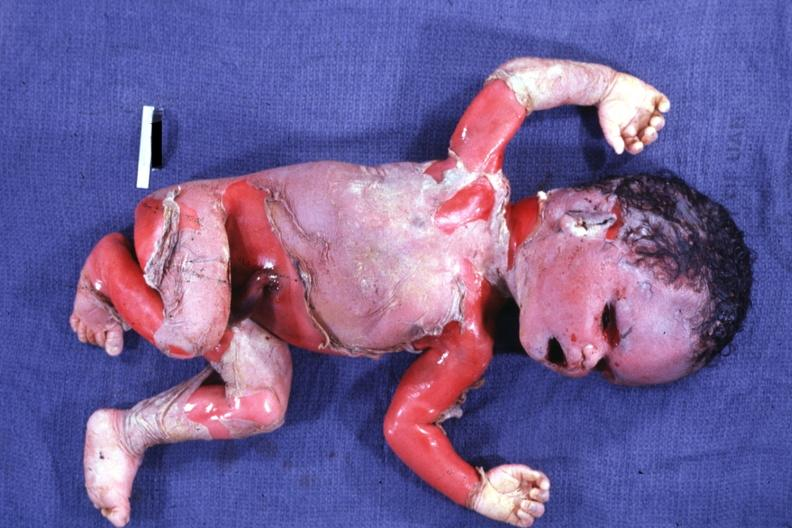s macerated stillborn present?
Answer the question using a single word or phrase. Yes 